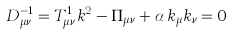<formula> <loc_0><loc_0><loc_500><loc_500>D _ { \mu \nu } ^ { - 1 } = T _ { \mu \nu } ^ { 1 } k ^ { 2 } - \Pi _ { \mu \nu } + \alpha \, k _ { \mu } k _ { \nu } = 0</formula> 